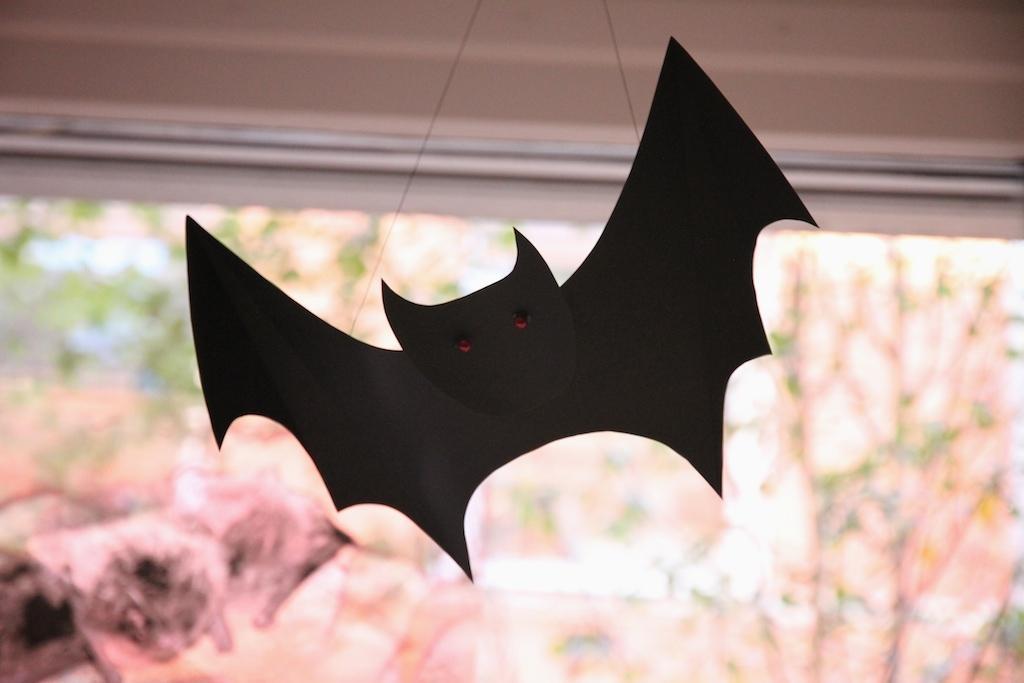Please provide a concise description of this image. In the foreground I can see a paper bat hanged on a rooftop and plants. At the top I can see a rooftop. This image is taken may be during a day. 